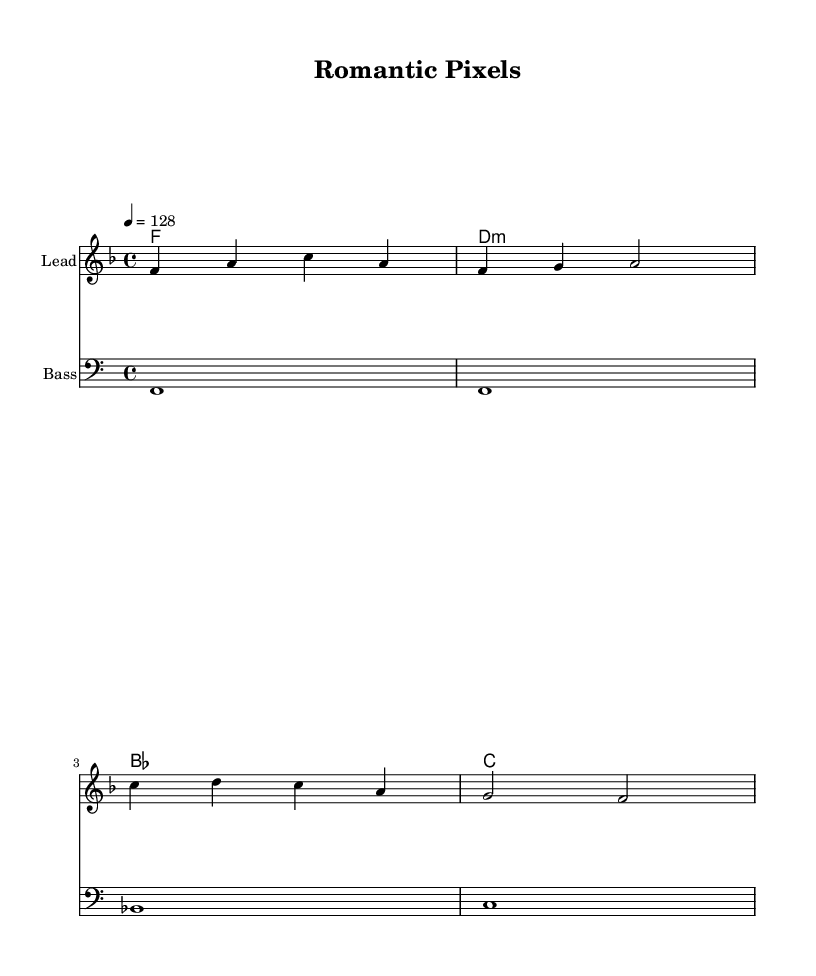What is the key signature of this music? The key signature is F major, which includes one flat (B flat). This can be determined by looking at the key signature indicated in the music, which shows the flat symbol corresponding to the note B.
Answer: F major What is the time signature of this music? The time signature is 4/4, which means there are four beats in each measure and the quarter note receives one beat. This is indicated at the beginning of the score.
Answer: 4/4 What is the tempo marking of this music? The tempo marking is 128 beats per minute, which is shown in the score where it indicates tempo as "4 = 128". This means the quarter note is the beat, and it should be played at a speed of 128 BPM.
Answer: 128 What is the first note of the melody? The first note of the melody is F. This can be identified by looking at the first note in the melody staff, which is located on the fourth line of the treble clef, corresponding to F.
Answer: F How many measures are in the melody? There are four measures in the melody. This can be determined by counting the vertical bar lines, which indicate the end of each measure.
Answer: 4 What chord follows the F major chord in harmony? The chord that follows is D minor. This can be found by analyzing the sequence of chords written in the chord names staff and noting that the D minor chord appears right after the F major chord.
Answer: D minor What instrument plays the bass line? The bass line is played by a bass instrument, as indicated in the staff where it is explicitly labeled "Bass".
Answer: Bass 